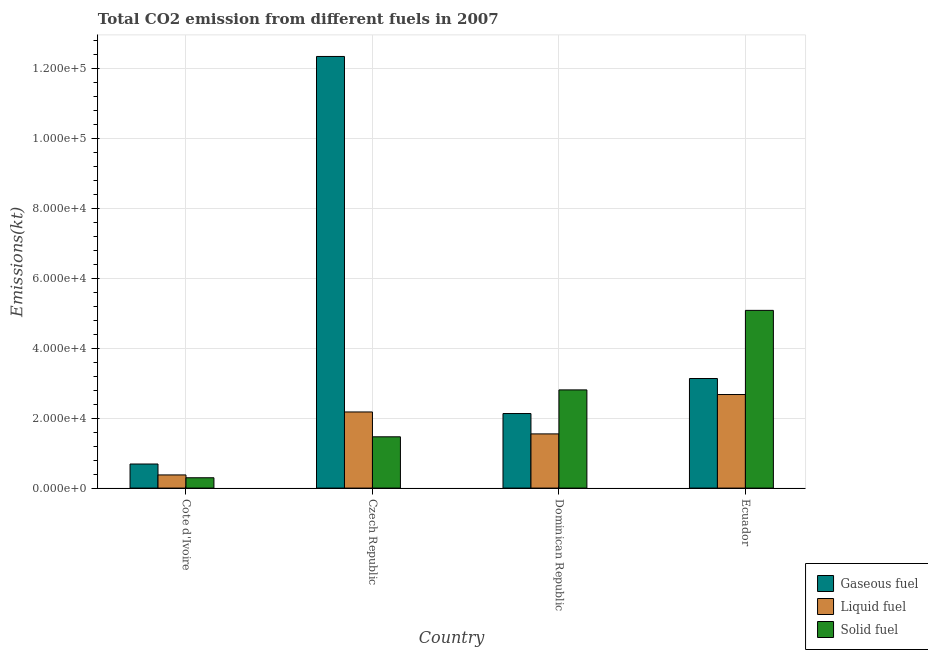How many bars are there on the 2nd tick from the left?
Make the answer very short. 3. How many bars are there on the 4th tick from the right?
Keep it short and to the point. 3. What is the label of the 1st group of bars from the left?
Your answer should be very brief. Cote d'Ivoire. What is the amount of co2 emissions from solid fuel in Dominican Republic?
Ensure brevity in your answer.  2.81e+04. Across all countries, what is the maximum amount of co2 emissions from solid fuel?
Your answer should be very brief. 5.08e+04. Across all countries, what is the minimum amount of co2 emissions from gaseous fuel?
Ensure brevity in your answer.  6882.96. In which country was the amount of co2 emissions from gaseous fuel maximum?
Offer a terse response. Czech Republic. In which country was the amount of co2 emissions from liquid fuel minimum?
Your answer should be very brief. Cote d'Ivoire. What is the total amount of co2 emissions from gaseous fuel in the graph?
Give a very brief answer. 1.83e+05. What is the difference between the amount of co2 emissions from liquid fuel in Cote d'Ivoire and that in Dominican Republic?
Provide a succinct answer. -1.17e+04. What is the difference between the amount of co2 emissions from gaseous fuel in Ecuador and the amount of co2 emissions from liquid fuel in Czech Republic?
Keep it short and to the point. 9556.2. What is the average amount of co2 emissions from solid fuel per country?
Offer a very short reply. 2.41e+04. What is the difference between the amount of co2 emissions from solid fuel and amount of co2 emissions from liquid fuel in Cote d'Ivoire?
Provide a succinct answer. -806.74. What is the ratio of the amount of co2 emissions from gaseous fuel in Dominican Republic to that in Ecuador?
Your response must be concise. 0.68. Is the amount of co2 emissions from liquid fuel in Cote d'Ivoire less than that in Ecuador?
Make the answer very short. Yes. Is the difference between the amount of co2 emissions from liquid fuel in Czech Republic and Ecuador greater than the difference between the amount of co2 emissions from gaseous fuel in Czech Republic and Ecuador?
Provide a short and direct response. No. What is the difference between the highest and the second highest amount of co2 emissions from gaseous fuel?
Your answer should be compact. 9.20e+04. What is the difference between the highest and the lowest amount of co2 emissions from liquid fuel?
Give a very brief answer. 2.30e+04. In how many countries, is the amount of co2 emissions from gaseous fuel greater than the average amount of co2 emissions from gaseous fuel taken over all countries?
Give a very brief answer. 1. What does the 3rd bar from the left in Cote d'Ivoire represents?
Your answer should be very brief. Solid fuel. What does the 1st bar from the right in Dominican Republic represents?
Make the answer very short. Solid fuel. How many bars are there?
Keep it short and to the point. 12. How many countries are there in the graph?
Keep it short and to the point. 4. Does the graph contain any zero values?
Make the answer very short. No. How are the legend labels stacked?
Offer a very short reply. Vertical. What is the title of the graph?
Ensure brevity in your answer.  Total CO2 emission from different fuels in 2007. What is the label or title of the Y-axis?
Your answer should be very brief. Emissions(kt). What is the Emissions(kt) in Gaseous fuel in Cote d'Ivoire?
Provide a succinct answer. 6882.96. What is the Emissions(kt) of Liquid fuel in Cote d'Ivoire?
Offer a terse response. 3758.68. What is the Emissions(kt) in Solid fuel in Cote d'Ivoire?
Provide a short and direct response. 2951.93. What is the Emissions(kt) of Gaseous fuel in Czech Republic?
Provide a succinct answer. 1.23e+05. What is the Emissions(kt) in Liquid fuel in Czech Republic?
Your response must be concise. 2.18e+04. What is the Emissions(kt) in Solid fuel in Czech Republic?
Give a very brief answer. 1.47e+04. What is the Emissions(kt) of Gaseous fuel in Dominican Republic?
Make the answer very short. 2.13e+04. What is the Emissions(kt) in Liquid fuel in Dominican Republic?
Your response must be concise. 1.55e+04. What is the Emissions(kt) in Solid fuel in Dominican Republic?
Your answer should be compact. 2.81e+04. What is the Emissions(kt) of Gaseous fuel in Ecuador?
Your answer should be compact. 3.13e+04. What is the Emissions(kt) in Liquid fuel in Ecuador?
Offer a terse response. 2.67e+04. What is the Emissions(kt) in Solid fuel in Ecuador?
Offer a terse response. 5.08e+04. Across all countries, what is the maximum Emissions(kt) in Gaseous fuel?
Make the answer very short. 1.23e+05. Across all countries, what is the maximum Emissions(kt) in Liquid fuel?
Offer a terse response. 2.67e+04. Across all countries, what is the maximum Emissions(kt) of Solid fuel?
Provide a short and direct response. 5.08e+04. Across all countries, what is the minimum Emissions(kt) in Gaseous fuel?
Provide a short and direct response. 6882.96. Across all countries, what is the minimum Emissions(kt) of Liquid fuel?
Provide a short and direct response. 3758.68. Across all countries, what is the minimum Emissions(kt) of Solid fuel?
Offer a terse response. 2951.93. What is the total Emissions(kt) in Gaseous fuel in the graph?
Offer a very short reply. 1.83e+05. What is the total Emissions(kt) of Liquid fuel in the graph?
Provide a short and direct response. 6.77e+04. What is the total Emissions(kt) of Solid fuel in the graph?
Offer a very short reply. 9.64e+04. What is the difference between the Emissions(kt) in Gaseous fuel in Cote d'Ivoire and that in Czech Republic?
Give a very brief answer. -1.16e+05. What is the difference between the Emissions(kt) in Liquid fuel in Cote d'Ivoire and that in Czech Republic?
Your answer should be very brief. -1.80e+04. What is the difference between the Emissions(kt) of Solid fuel in Cote d'Ivoire and that in Czech Republic?
Offer a very short reply. -1.17e+04. What is the difference between the Emissions(kt) of Gaseous fuel in Cote d'Ivoire and that in Dominican Republic?
Ensure brevity in your answer.  -1.44e+04. What is the difference between the Emissions(kt) in Liquid fuel in Cote d'Ivoire and that in Dominican Republic?
Your answer should be compact. -1.17e+04. What is the difference between the Emissions(kt) in Solid fuel in Cote d'Ivoire and that in Dominican Republic?
Ensure brevity in your answer.  -2.51e+04. What is the difference between the Emissions(kt) of Gaseous fuel in Cote d'Ivoire and that in Ecuador?
Keep it short and to the point. -2.44e+04. What is the difference between the Emissions(kt) of Liquid fuel in Cote d'Ivoire and that in Ecuador?
Your answer should be very brief. -2.30e+04. What is the difference between the Emissions(kt) of Solid fuel in Cote d'Ivoire and that in Ecuador?
Provide a short and direct response. -4.78e+04. What is the difference between the Emissions(kt) of Gaseous fuel in Czech Republic and that in Dominican Republic?
Give a very brief answer. 1.02e+05. What is the difference between the Emissions(kt) in Liquid fuel in Czech Republic and that in Dominican Republic?
Your answer should be very brief. 6270.57. What is the difference between the Emissions(kt) in Solid fuel in Czech Republic and that in Dominican Republic?
Keep it short and to the point. -1.34e+04. What is the difference between the Emissions(kt) in Gaseous fuel in Czech Republic and that in Ecuador?
Ensure brevity in your answer.  9.20e+04. What is the difference between the Emissions(kt) of Liquid fuel in Czech Republic and that in Ecuador?
Your response must be concise. -4979.79. What is the difference between the Emissions(kt) in Solid fuel in Czech Republic and that in Ecuador?
Offer a terse response. -3.61e+04. What is the difference between the Emissions(kt) in Gaseous fuel in Dominican Republic and that in Ecuador?
Make the answer very short. -1.00e+04. What is the difference between the Emissions(kt) of Liquid fuel in Dominican Republic and that in Ecuador?
Your response must be concise. -1.13e+04. What is the difference between the Emissions(kt) in Solid fuel in Dominican Republic and that in Ecuador?
Provide a short and direct response. -2.27e+04. What is the difference between the Emissions(kt) of Gaseous fuel in Cote d'Ivoire and the Emissions(kt) of Liquid fuel in Czech Republic?
Your answer should be compact. -1.49e+04. What is the difference between the Emissions(kt) in Gaseous fuel in Cote d'Ivoire and the Emissions(kt) in Solid fuel in Czech Republic?
Keep it short and to the point. -7770.37. What is the difference between the Emissions(kt) in Liquid fuel in Cote d'Ivoire and the Emissions(kt) in Solid fuel in Czech Republic?
Provide a succinct answer. -1.09e+04. What is the difference between the Emissions(kt) in Gaseous fuel in Cote d'Ivoire and the Emissions(kt) in Liquid fuel in Dominican Republic?
Provide a short and direct response. -8599.11. What is the difference between the Emissions(kt) of Gaseous fuel in Cote d'Ivoire and the Emissions(kt) of Solid fuel in Dominican Republic?
Make the answer very short. -2.12e+04. What is the difference between the Emissions(kt) in Liquid fuel in Cote d'Ivoire and the Emissions(kt) in Solid fuel in Dominican Republic?
Give a very brief answer. -2.43e+04. What is the difference between the Emissions(kt) in Gaseous fuel in Cote d'Ivoire and the Emissions(kt) in Liquid fuel in Ecuador?
Ensure brevity in your answer.  -1.98e+04. What is the difference between the Emissions(kt) in Gaseous fuel in Cote d'Ivoire and the Emissions(kt) in Solid fuel in Ecuador?
Ensure brevity in your answer.  -4.39e+04. What is the difference between the Emissions(kt) of Liquid fuel in Cote d'Ivoire and the Emissions(kt) of Solid fuel in Ecuador?
Offer a very short reply. -4.70e+04. What is the difference between the Emissions(kt) of Gaseous fuel in Czech Republic and the Emissions(kt) of Liquid fuel in Dominican Republic?
Provide a short and direct response. 1.08e+05. What is the difference between the Emissions(kt) of Gaseous fuel in Czech Republic and the Emissions(kt) of Solid fuel in Dominican Republic?
Give a very brief answer. 9.53e+04. What is the difference between the Emissions(kt) in Liquid fuel in Czech Republic and the Emissions(kt) in Solid fuel in Dominican Republic?
Offer a terse response. -6303.57. What is the difference between the Emissions(kt) of Gaseous fuel in Czech Republic and the Emissions(kt) of Liquid fuel in Ecuador?
Your answer should be compact. 9.66e+04. What is the difference between the Emissions(kt) in Gaseous fuel in Czech Republic and the Emissions(kt) in Solid fuel in Ecuador?
Give a very brief answer. 7.25e+04. What is the difference between the Emissions(kt) of Liquid fuel in Czech Republic and the Emissions(kt) of Solid fuel in Ecuador?
Offer a terse response. -2.90e+04. What is the difference between the Emissions(kt) of Gaseous fuel in Dominican Republic and the Emissions(kt) of Liquid fuel in Ecuador?
Ensure brevity in your answer.  -5430.83. What is the difference between the Emissions(kt) of Gaseous fuel in Dominican Republic and the Emissions(kt) of Solid fuel in Ecuador?
Offer a very short reply. -2.95e+04. What is the difference between the Emissions(kt) in Liquid fuel in Dominican Republic and the Emissions(kt) in Solid fuel in Ecuador?
Ensure brevity in your answer.  -3.53e+04. What is the average Emissions(kt) in Gaseous fuel per country?
Your answer should be very brief. 4.57e+04. What is the average Emissions(kt) in Liquid fuel per country?
Offer a terse response. 1.69e+04. What is the average Emissions(kt) in Solid fuel per country?
Provide a short and direct response. 2.41e+04. What is the difference between the Emissions(kt) of Gaseous fuel and Emissions(kt) of Liquid fuel in Cote d'Ivoire?
Provide a succinct answer. 3124.28. What is the difference between the Emissions(kt) in Gaseous fuel and Emissions(kt) in Solid fuel in Cote d'Ivoire?
Provide a succinct answer. 3931.02. What is the difference between the Emissions(kt) in Liquid fuel and Emissions(kt) in Solid fuel in Cote d'Ivoire?
Ensure brevity in your answer.  806.74. What is the difference between the Emissions(kt) of Gaseous fuel and Emissions(kt) of Liquid fuel in Czech Republic?
Your response must be concise. 1.02e+05. What is the difference between the Emissions(kt) of Gaseous fuel and Emissions(kt) of Solid fuel in Czech Republic?
Your response must be concise. 1.09e+05. What is the difference between the Emissions(kt) in Liquid fuel and Emissions(kt) in Solid fuel in Czech Republic?
Give a very brief answer. 7099.31. What is the difference between the Emissions(kt) of Gaseous fuel and Emissions(kt) of Liquid fuel in Dominican Republic?
Offer a terse response. 5819.53. What is the difference between the Emissions(kt) in Gaseous fuel and Emissions(kt) in Solid fuel in Dominican Republic?
Make the answer very short. -6754.61. What is the difference between the Emissions(kt) of Liquid fuel and Emissions(kt) of Solid fuel in Dominican Republic?
Give a very brief answer. -1.26e+04. What is the difference between the Emissions(kt) in Gaseous fuel and Emissions(kt) in Liquid fuel in Ecuador?
Offer a very short reply. 4576.42. What is the difference between the Emissions(kt) in Gaseous fuel and Emissions(kt) in Solid fuel in Ecuador?
Offer a very short reply. -1.95e+04. What is the difference between the Emissions(kt) of Liquid fuel and Emissions(kt) of Solid fuel in Ecuador?
Give a very brief answer. -2.40e+04. What is the ratio of the Emissions(kt) in Gaseous fuel in Cote d'Ivoire to that in Czech Republic?
Offer a very short reply. 0.06. What is the ratio of the Emissions(kt) in Liquid fuel in Cote d'Ivoire to that in Czech Republic?
Provide a succinct answer. 0.17. What is the ratio of the Emissions(kt) of Solid fuel in Cote d'Ivoire to that in Czech Republic?
Provide a succinct answer. 0.2. What is the ratio of the Emissions(kt) of Gaseous fuel in Cote d'Ivoire to that in Dominican Republic?
Your answer should be compact. 0.32. What is the ratio of the Emissions(kt) of Liquid fuel in Cote d'Ivoire to that in Dominican Republic?
Your response must be concise. 0.24. What is the ratio of the Emissions(kt) in Solid fuel in Cote d'Ivoire to that in Dominican Republic?
Offer a very short reply. 0.11. What is the ratio of the Emissions(kt) in Gaseous fuel in Cote d'Ivoire to that in Ecuador?
Offer a very short reply. 0.22. What is the ratio of the Emissions(kt) of Liquid fuel in Cote d'Ivoire to that in Ecuador?
Give a very brief answer. 0.14. What is the ratio of the Emissions(kt) of Solid fuel in Cote d'Ivoire to that in Ecuador?
Your answer should be very brief. 0.06. What is the ratio of the Emissions(kt) of Gaseous fuel in Czech Republic to that in Dominican Republic?
Provide a succinct answer. 5.79. What is the ratio of the Emissions(kt) in Liquid fuel in Czech Republic to that in Dominican Republic?
Your response must be concise. 1.41. What is the ratio of the Emissions(kt) of Solid fuel in Czech Republic to that in Dominican Republic?
Offer a very short reply. 0.52. What is the ratio of the Emissions(kt) in Gaseous fuel in Czech Republic to that in Ecuador?
Give a very brief answer. 3.94. What is the ratio of the Emissions(kt) of Liquid fuel in Czech Republic to that in Ecuador?
Make the answer very short. 0.81. What is the ratio of the Emissions(kt) in Solid fuel in Czech Republic to that in Ecuador?
Provide a short and direct response. 0.29. What is the ratio of the Emissions(kt) in Gaseous fuel in Dominican Republic to that in Ecuador?
Your response must be concise. 0.68. What is the ratio of the Emissions(kt) in Liquid fuel in Dominican Republic to that in Ecuador?
Make the answer very short. 0.58. What is the ratio of the Emissions(kt) of Solid fuel in Dominican Republic to that in Ecuador?
Your response must be concise. 0.55. What is the difference between the highest and the second highest Emissions(kt) in Gaseous fuel?
Provide a succinct answer. 9.20e+04. What is the difference between the highest and the second highest Emissions(kt) of Liquid fuel?
Your answer should be very brief. 4979.79. What is the difference between the highest and the second highest Emissions(kt) in Solid fuel?
Your answer should be very brief. 2.27e+04. What is the difference between the highest and the lowest Emissions(kt) in Gaseous fuel?
Your response must be concise. 1.16e+05. What is the difference between the highest and the lowest Emissions(kt) of Liquid fuel?
Offer a terse response. 2.30e+04. What is the difference between the highest and the lowest Emissions(kt) in Solid fuel?
Ensure brevity in your answer.  4.78e+04. 